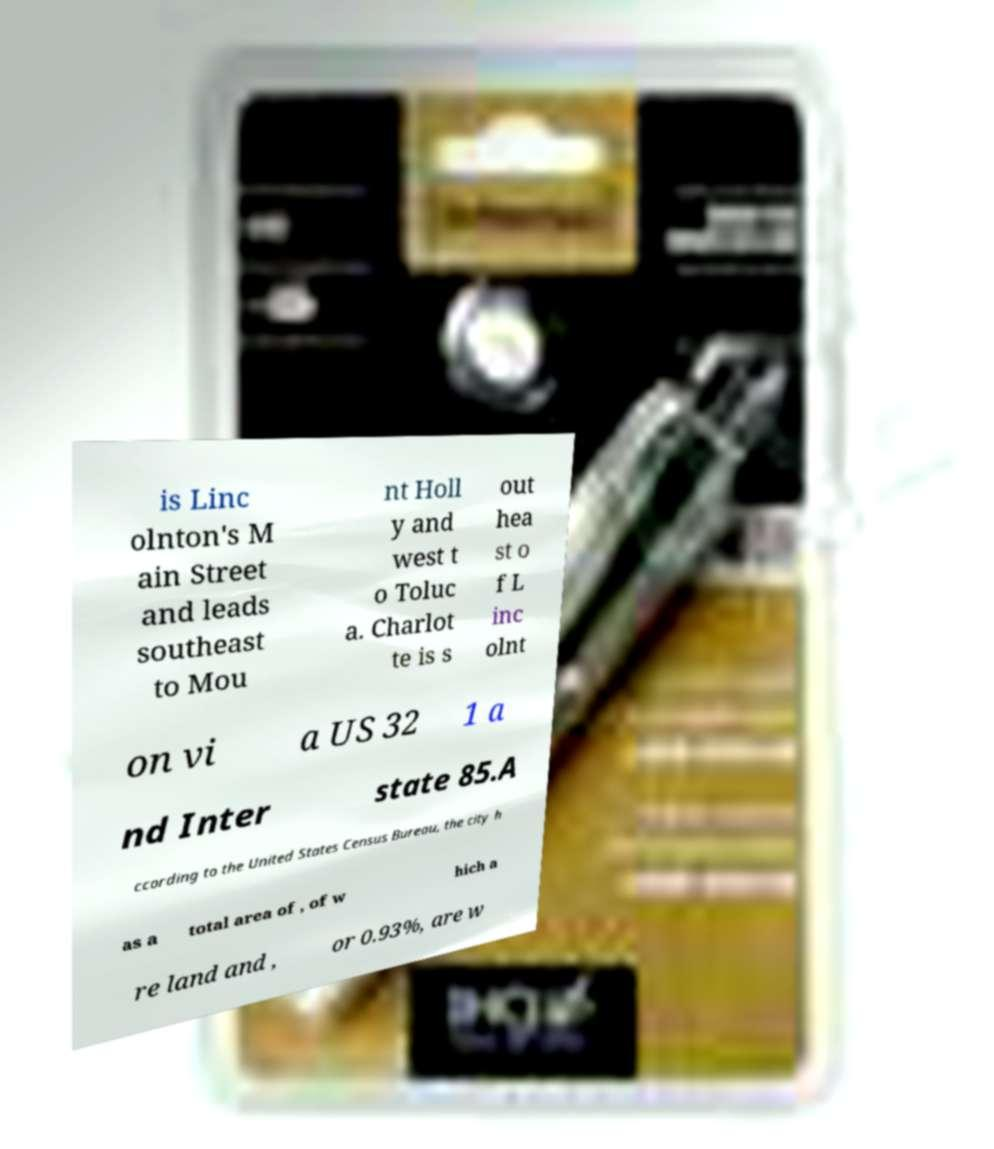There's text embedded in this image that I need extracted. Can you transcribe it verbatim? is Linc olnton's M ain Street and leads southeast to Mou nt Holl y and west t o Toluc a. Charlot te is s out hea st o f L inc olnt on vi a US 32 1 a nd Inter state 85.A ccording to the United States Census Bureau, the city h as a total area of , of w hich a re land and , or 0.93%, are w 